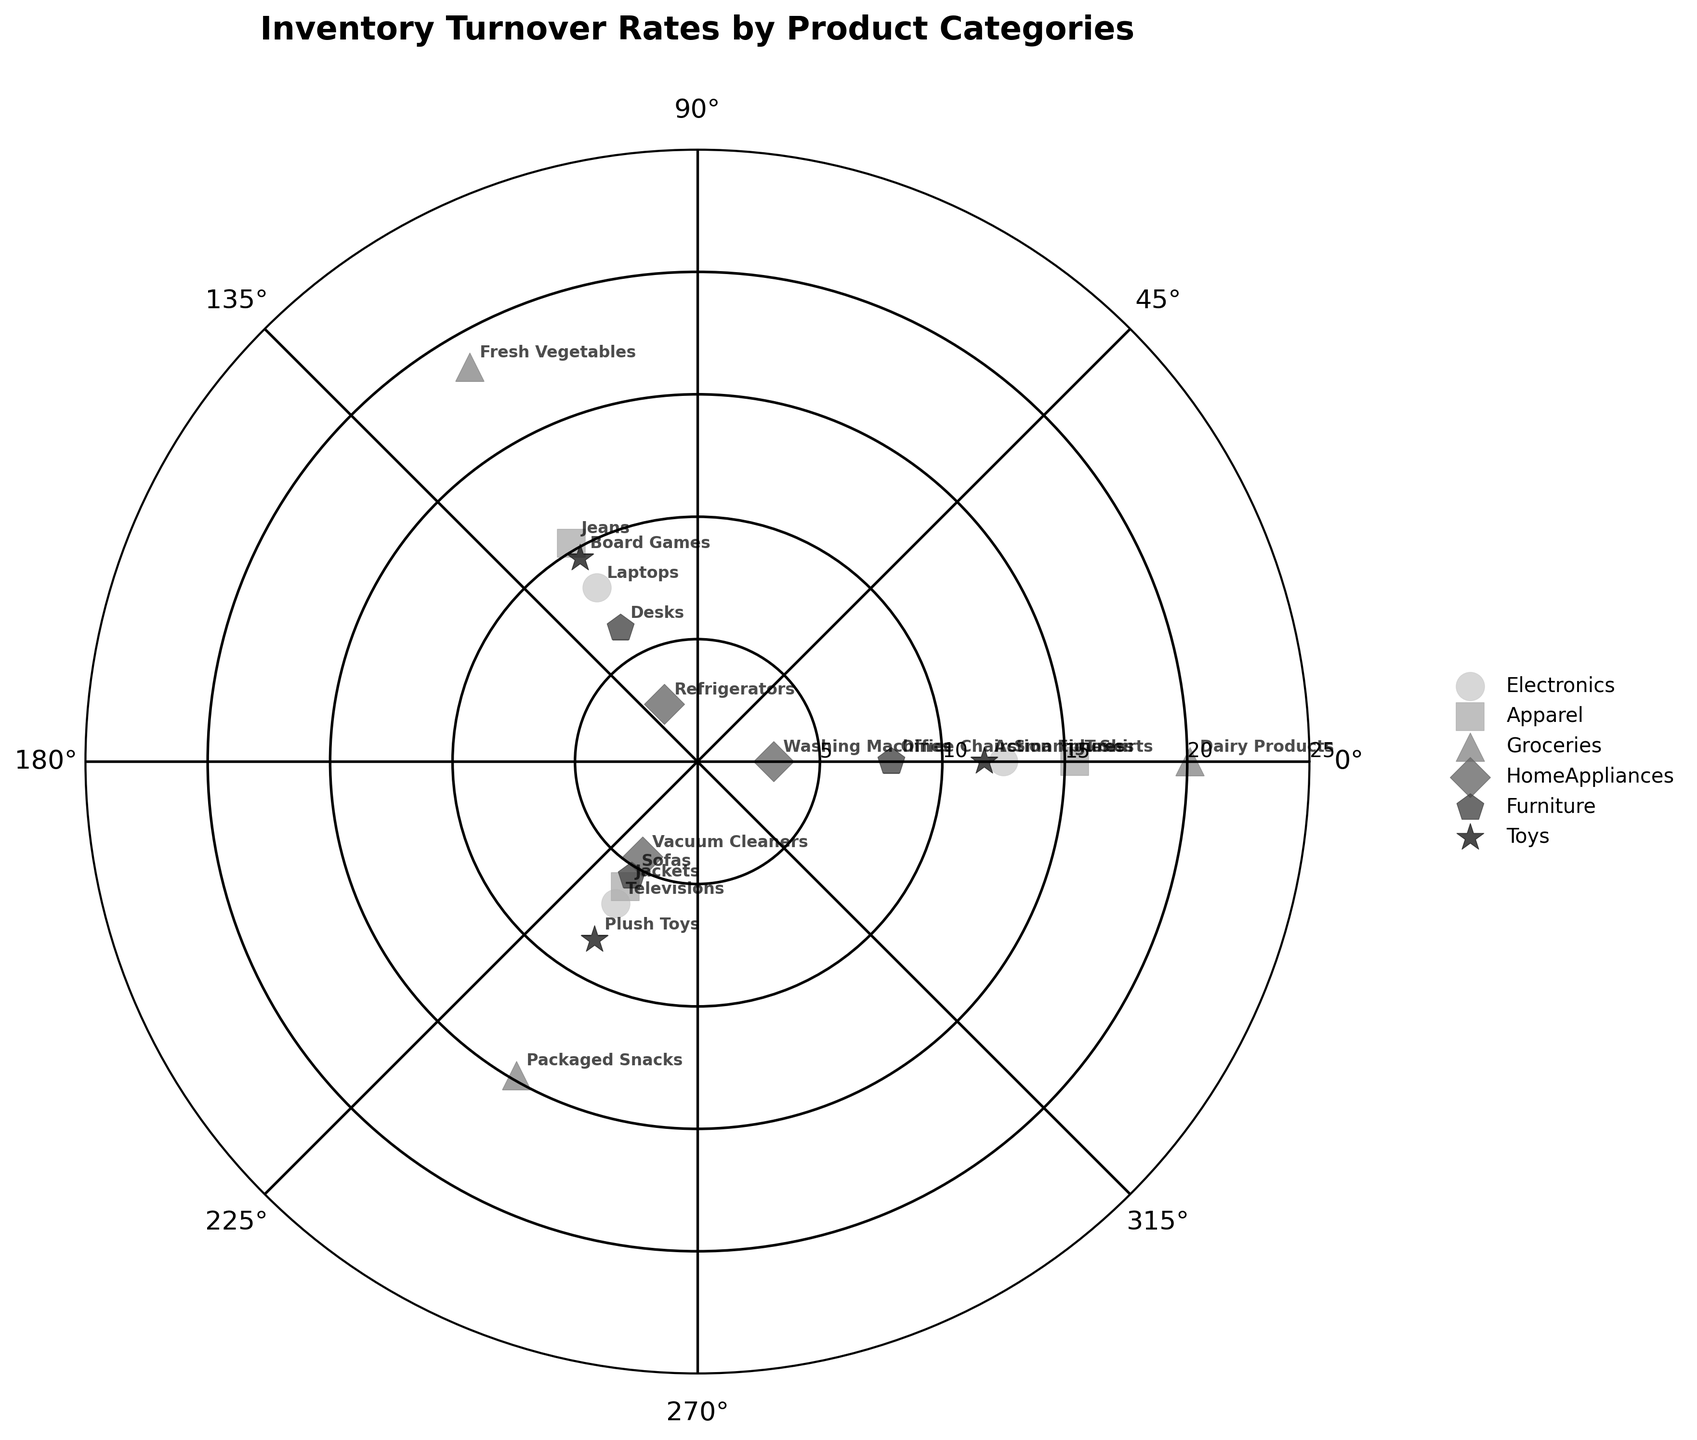What is the title of the chart? The title of the chart is typically located at the top of the figure and is used to describe the content or purpose of the chart. In this case, it reads "Inventory Turnover Rates by Product Categories".
Answer: "Inventory Turnover Rates by Product Categories" How many product categories are represented in the plot? By looking at the legend on the chart, which lists each unique product category, we can count the total number of categories. The legend has six entries.
Answer: Six Which product category has the highest inventory turnover rate? By locating the data points that are the farthest from the center (highest radial distance) and checking their labels, the product with the highest turnover rate belongs to the Groceries category.
Answer: Groceries What is the inventory turnover rate for Smartphones? Find the marker in the Electronics category and the label corresponding to Smartphones, then read the radial distance from the center which represents the turnover rate.
Answer: 12.5 Compare the turnover rates of Office Chairs and Desks. Which has a higher value? Locate both Office Chairs and Desks in the Furniture category by their labels and compare their radial distances from the center. Office Chairs has a higher radial distance.
Answer: Office Chairs What is the average inventory turnover rate for products in the Apparel category? First, locate all products in the Apparel category by their labels (T-Shirts, Jeans, Jackets). Then sum their turnover rates: 15.4 + 10.3 + 5.9 = 31.6. Finally, divide by the number of products (3): 31.6 / 3 = 10.53.
Answer: 10.53 What is the range of turnover rates in the HomeAppliances category? Find the minimum and maximum turnover rates for HomeAppliances category. Minimum is 2.7 (Refrigerators) and maximum is 4.5 (Vacuum Cleaners), so the range is 4.5 - 2.7 = 1.8.
Answer: 1.8 Are there any categories where all products have turnover rates above 10? Check each product within a category for turnover rates. The Groceries category has all products (Dairy Products, Fresh Vegetables, Packaged Snacks) with turnover rates above 10.
Answer: Groceries Estimate the median inventory turnover rate of all products combined. Arrange all inventory turnover rates in ascending order and find the middle value. The list in order: 2.7, 3.1, 4.5, 5.4, 5.9, 6.3, 6.7, 7.9, 8.2, 8.4, 9.6, 10.3, 11.7, 12.5, 14.8, 15.4, 18.6, 20.1. The median value (middle of 18 values) is the average of the 9th and 10th values: (8.4 + 9.6) / 2 = 9.
Answer: 9 